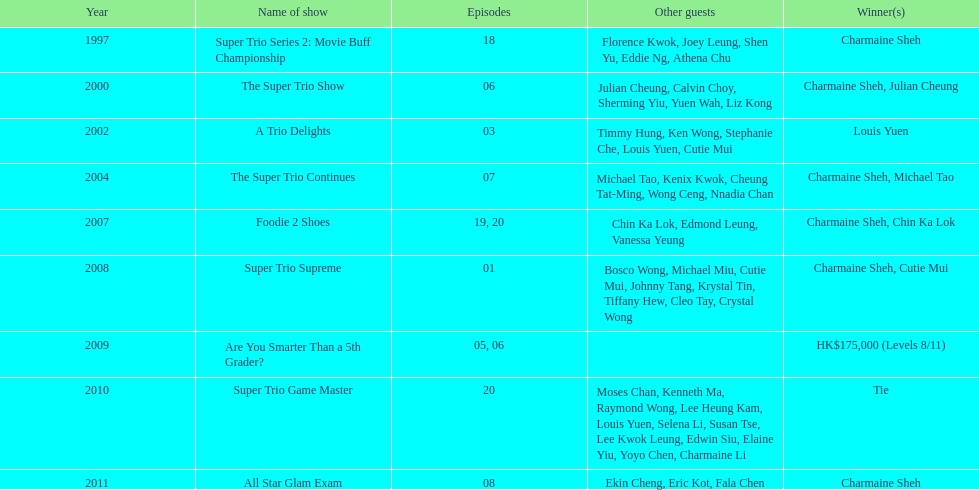How much time has passed since charmaine sheh initially featured on a variety show? 17 years. 